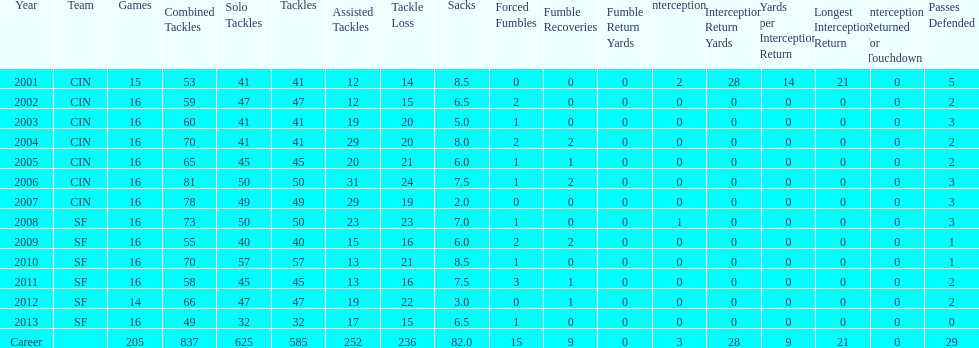How many consecutive years were there 20 or more assisted tackles? 5. 